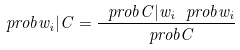<formula> <loc_0><loc_0><loc_500><loc_500>\ p r o b { w _ { i } | C } = \frac { \ p r o b { C | w _ { i } } \ p r o b { w _ { i } } } { \ p r o b { C } }</formula> 